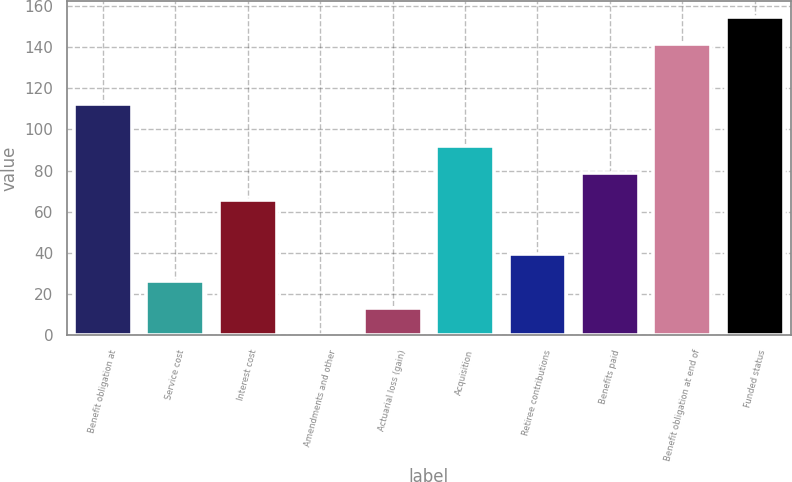Convert chart to OTSL. <chart><loc_0><loc_0><loc_500><loc_500><bar_chart><fcel>Benefit obligation at<fcel>Service cost<fcel>Interest cost<fcel>Amendments and other<fcel>Actuarial loss (gain)<fcel>Acquisition<fcel>Retiree contributions<fcel>Benefits paid<fcel>Benefit obligation at end of<fcel>Funded status<nl><fcel>112.3<fcel>26.48<fcel>65.75<fcel>0.3<fcel>13.39<fcel>91.93<fcel>39.57<fcel>78.84<fcel>141.39<fcel>154.48<nl></chart> 